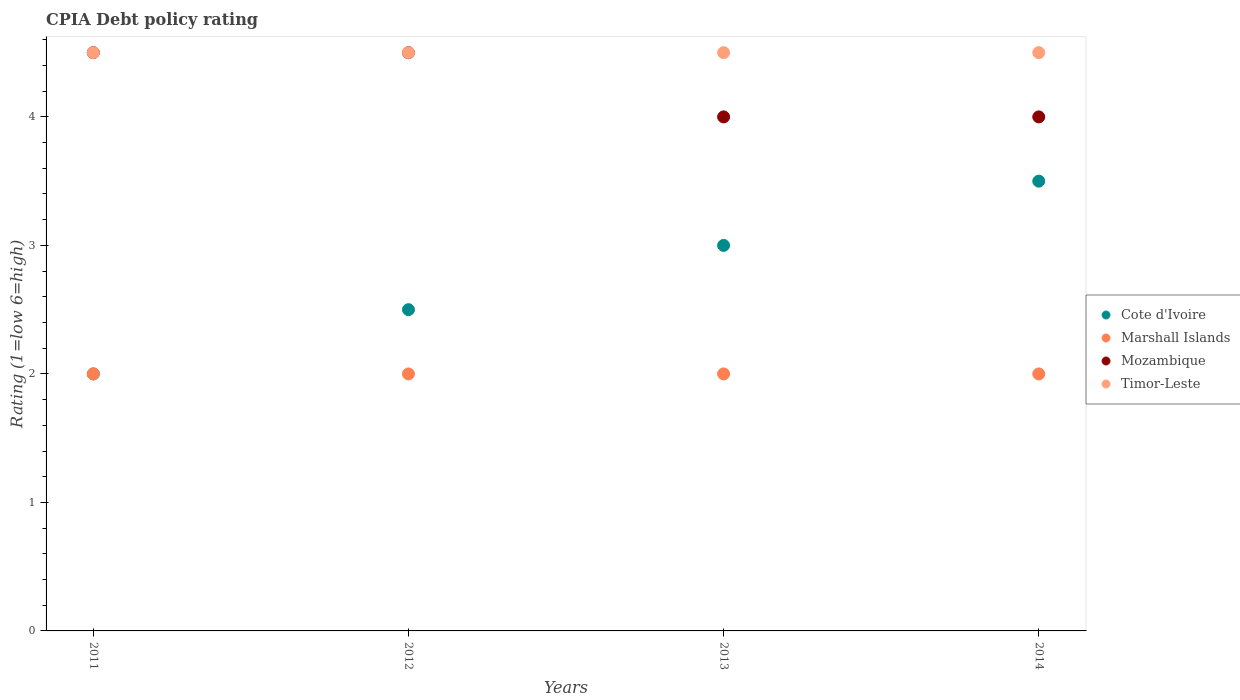Is the number of dotlines equal to the number of legend labels?
Keep it short and to the point. Yes. Across all years, what is the maximum CPIA rating in Timor-Leste?
Offer a terse response. 4.5. In which year was the CPIA rating in Timor-Leste maximum?
Offer a terse response. 2011. What is the difference between the CPIA rating in Cote d'Ivoire in 2012 and that in 2014?
Keep it short and to the point. -1. What is the difference between the CPIA rating in Cote d'Ivoire in 2011 and the CPIA rating in Mozambique in 2014?
Your response must be concise. -2. In the year 2014, what is the difference between the CPIA rating in Mozambique and CPIA rating in Timor-Leste?
Provide a short and direct response. -0.5. What is the ratio of the CPIA rating in Timor-Leste in 2013 to that in 2014?
Ensure brevity in your answer.  1. Is the CPIA rating in Cote d'Ivoire in 2013 less than that in 2014?
Provide a short and direct response. Yes. In how many years, is the CPIA rating in Timor-Leste greater than the average CPIA rating in Timor-Leste taken over all years?
Provide a short and direct response. 0. Is the sum of the CPIA rating in Marshall Islands in 2013 and 2014 greater than the maximum CPIA rating in Mozambique across all years?
Your response must be concise. No. Is it the case that in every year, the sum of the CPIA rating in Mozambique and CPIA rating in Timor-Leste  is greater than the sum of CPIA rating in Marshall Islands and CPIA rating in Cote d'Ivoire?
Your answer should be very brief. No. Does the CPIA rating in Timor-Leste monotonically increase over the years?
Your response must be concise. No. Is the CPIA rating in Cote d'Ivoire strictly greater than the CPIA rating in Timor-Leste over the years?
Give a very brief answer. No. Is the CPIA rating in Timor-Leste strictly less than the CPIA rating in Mozambique over the years?
Ensure brevity in your answer.  No. How many years are there in the graph?
Offer a very short reply. 4. What is the difference between two consecutive major ticks on the Y-axis?
Your response must be concise. 1. Are the values on the major ticks of Y-axis written in scientific E-notation?
Provide a short and direct response. No. Does the graph contain any zero values?
Offer a very short reply. No. Does the graph contain grids?
Your answer should be very brief. No. Where does the legend appear in the graph?
Your response must be concise. Center right. What is the title of the graph?
Offer a terse response. CPIA Debt policy rating. What is the Rating (1=low 6=high) of Marshall Islands in 2011?
Give a very brief answer. 2. What is the Rating (1=low 6=high) of Mozambique in 2011?
Your response must be concise. 4.5. What is the Rating (1=low 6=high) of Timor-Leste in 2011?
Offer a very short reply. 4.5. What is the Rating (1=low 6=high) of Cote d'Ivoire in 2012?
Keep it short and to the point. 2.5. What is the Rating (1=low 6=high) in Marshall Islands in 2012?
Provide a succinct answer. 2. What is the Rating (1=low 6=high) of Mozambique in 2012?
Your answer should be very brief. 4.5. What is the Rating (1=low 6=high) in Timor-Leste in 2012?
Your answer should be compact. 4.5. What is the Rating (1=low 6=high) of Timor-Leste in 2013?
Your answer should be compact. 4.5. What is the Rating (1=low 6=high) in Mozambique in 2014?
Offer a terse response. 4. Across all years, what is the maximum Rating (1=low 6=high) in Marshall Islands?
Your response must be concise. 2. Across all years, what is the maximum Rating (1=low 6=high) in Mozambique?
Provide a succinct answer. 4.5. What is the total Rating (1=low 6=high) of Mozambique in the graph?
Offer a terse response. 17. What is the difference between the Rating (1=low 6=high) of Mozambique in 2011 and that in 2012?
Offer a very short reply. 0. What is the difference between the Rating (1=low 6=high) in Cote d'Ivoire in 2011 and that in 2014?
Provide a short and direct response. -1.5. What is the difference between the Rating (1=low 6=high) of Mozambique in 2011 and that in 2014?
Provide a short and direct response. 0.5. What is the difference between the Rating (1=low 6=high) in Timor-Leste in 2011 and that in 2014?
Provide a succinct answer. 0. What is the difference between the Rating (1=low 6=high) in Cote d'Ivoire in 2012 and that in 2014?
Provide a succinct answer. -1. What is the difference between the Rating (1=low 6=high) of Marshall Islands in 2012 and that in 2014?
Provide a short and direct response. 0. What is the difference between the Rating (1=low 6=high) of Mozambique in 2012 and that in 2014?
Make the answer very short. 0.5. What is the difference between the Rating (1=low 6=high) of Timor-Leste in 2013 and that in 2014?
Your response must be concise. 0. What is the difference between the Rating (1=low 6=high) of Cote d'Ivoire in 2011 and the Rating (1=low 6=high) of Marshall Islands in 2012?
Keep it short and to the point. 0. What is the difference between the Rating (1=low 6=high) of Cote d'Ivoire in 2011 and the Rating (1=low 6=high) of Mozambique in 2012?
Provide a short and direct response. -2.5. What is the difference between the Rating (1=low 6=high) of Marshall Islands in 2011 and the Rating (1=low 6=high) of Mozambique in 2012?
Offer a terse response. -2.5. What is the difference between the Rating (1=low 6=high) in Marshall Islands in 2011 and the Rating (1=low 6=high) in Timor-Leste in 2012?
Ensure brevity in your answer.  -2.5. What is the difference between the Rating (1=low 6=high) of Cote d'Ivoire in 2011 and the Rating (1=low 6=high) of Mozambique in 2013?
Offer a terse response. -2. What is the difference between the Rating (1=low 6=high) of Cote d'Ivoire in 2011 and the Rating (1=low 6=high) of Timor-Leste in 2013?
Your answer should be very brief. -2.5. What is the difference between the Rating (1=low 6=high) of Mozambique in 2011 and the Rating (1=low 6=high) of Timor-Leste in 2013?
Offer a very short reply. 0. What is the difference between the Rating (1=low 6=high) of Cote d'Ivoire in 2011 and the Rating (1=low 6=high) of Mozambique in 2014?
Ensure brevity in your answer.  -2. What is the difference between the Rating (1=low 6=high) of Cote d'Ivoire in 2011 and the Rating (1=low 6=high) of Timor-Leste in 2014?
Make the answer very short. -2.5. What is the difference between the Rating (1=low 6=high) in Marshall Islands in 2011 and the Rating (1=low 6=high) in Timor-Leste in 2014?
Give a very brief answer. -2.5. What is the difference between the Rating (1=low 6=high) of Mozambique in 2011 and the Rating (1=low 6=high) of Timor-Leste in 2014?
Make the answer very short. 0. What is the difference between the Rating (1=low 6=high) in Cote d'Ivoire in 2012 and the Rating (1=low 6=high) in Marshall Islands in 2014?
Offer a terse response. 0.5. What is the difference between the Rating (1=low 6=high) of Marshall Islands in 2012 and the Rating (1=low 6=high) of Mozambique in 2014?
Give a very brief answer. -2. What is the difference between the Rating (1=low 6=high) of Mozambique in 2012 and the Rating (1=low 6=high) of Timor-Leste in 2014?
Keep it short and to the point. 0. What is the difference between the Rating (1=low 6=high) of Cote d'Ivoire in 2013 and the Rating (1=low 6=high) of Mozambique in 2014?
Make the answer very short. -1. What is the difference between the Rating (1=low 6=high) of Marshall Islands in 2013 and the Rating (1=low 6=high) of Mozambique in 2014?
Offer a terse response. -2. What is the difference between the Rating (1=low 6=high) in Marshall Islands in 2013 and the Rating (1=low 6=high) in Timor-Leste in 2014?
Give a very brief answer. -2.5. What is the average Rating (1=low 6=high) in Cote d'Ivoire per year?
Offer a terse response. 2.75. What is the average Rating (1=low 6=high) in Mozambique per year?
Your answer should be compact. 4.25. In the year 2011, what is the difference between the Rating (1=low 6=high) of Cote d'Ivoire and Rating (1=low 6=high) of Marshall Islands?
Offer a terse response. 0. In the year 2011, what is the difference between the Rating (1=low 6=high) in Cote d'Ivoire and Rating (1=low 6=high) in Mozambique?
Your response must be concise. -2.5. In the year 2011, what is the difference between the Rating (1=low 6=high) of Cote d'Ivoire and Rating (1=low 6=high) of Timor-Leste?
Offer a terse response. -2.5. In the year 2011, what is the difference between the Rating (1=low 6=high) in Marshall Islands and Rating (1=low 6=high) in Timor-Leste?
Offer a very short reply. -2.5. In the year 2012, what is the difference between the Rating (1=low 6=high) of Cote d'Ivoire and Rating (1=low 6=high) of Marshall Islands?
Ensure brevity in your answer.  0.5. In the year 2012, what is the difference between the Rating (1=low 6=high) in Mozambique and Rating (1=low 6=high) in Timor-Leste?
Ensure brevity in your answer.  0. In the year 2013, what is the difference between the Rating (1=low 6=high) in Cote d'Ivoire and Rating (1=low 6=high) in Mozambique?
Offer a terse response. -1. In the year 2013, what is the difference between the Rating (1=low 6=high) in Cote d'Ivoire and Rating (1=low 6=high) in Timor-Leste?
Your answer should be very brief. -1.5. In the year 2013, what is the difference between the Rating (1=low 6=high) of Marshall Islands and Rating (1=low 6=high) of Mozambique?
Provide a short and direct response. -2. In the year 2013, what is the difference between the Rating (1=low 6=high) of Marshall Islands and Rating (1=low 6=high) of Timor-Leste?
Give a very brief answer. -2.5. In the year 2014, what is the difference between the Rating (1=low 6=high) of Cote d'Ivoire and Rating (1=low 6=high) of Marshall Islands?
Provide a succinct answer. 1.5. In the year 2014, what is the difference between the Rating (1=low 6=high) in Marshall Islands and Rating (1=low 6=high) in Timor-Leste?
Offer a terse response. -2.5. What is the ratio of the Rating (1=low 6=high) of Marshall Islands in 2011 to that in 2012?
Your answer should be compact. 1. What is the ratio of the Rating (1=low 6=high) of Mozambique in 2011 to that in 2012?
Make the answer very short. 1. What is the ratio of the Rating (1=low 6=high) in Marshall Islands in 2011 to that in 2013?
Ensure brevity in your answer.  1. What is the ratio of the Rating (1=low 6=high) of Timor-Leste in 2011 to that in 2013?
Offer a terse response. 1. What is the ratio of the Rating (1=low 6=high) in Mozambique in 2011 to that in 2014?
Give a very brief answer. 1.12. What is the ratio of the Rating (1=low 6=high) in Timor-Leste in 2011 to that in 2014?
Make the answer very short. 1. What is the ratio of the Rating (1=low 6=high) of Timor-Leste in 2012 to that in 2013?
Keep it short and to the point. 1. What is the ratio of the Rating (1=low 6=high) of Timor-Leste in 2012 to that in 2014?
Give a very brief answer. 1. What is the ratio of the Rating (1=low 6=high) in Marshall Islands in 2013 to that in 2014?
Offer a very short reply. 1. What is the ratio of the Rating (1=low 6=high) in Mozambique in 2013 to that in 2014?
Keep it short and to the point. 1. What is the ratio of the Rating (1=low 6=high) in Timor-Leste in 2013 to that in 2014?
Provide a succinct answer. 1. What is the difference between the highest and the second highest Rating (1=low 6=high) of Cote d'Ivoire?
Make the answer very short. 0.5. What is the difference between the highest and the second highest Rating (1=low 6=high) of Marshall Islands?
Offer a terse response. 0. What is the difference between the highest and the second highest Rating (1=low 6=high) of Mozambique?
Give a very brief answer. 0. What is the difference between the highest and the lowest Rating (1=low 6=high) of Marshall Islands?
Your response must be concise. 0. What is the difference between the highest and the lowest Rating (1=low 6=high) of Mozambique?
Your answer should be very brief. 0.5. 